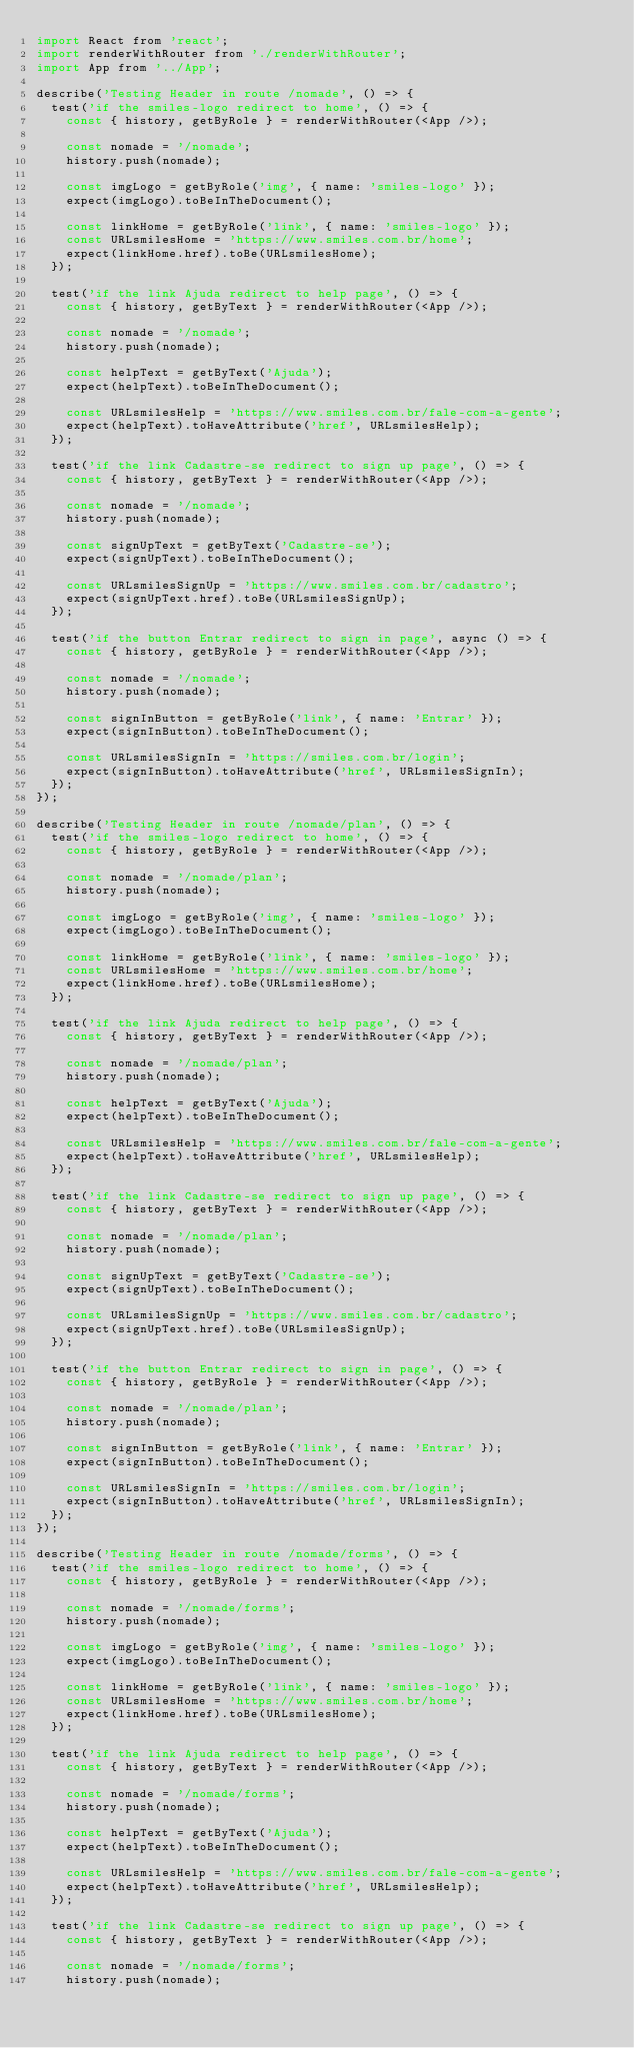Convert code to text. <code><loc_0><loc_0><loc_500><loc_500><_JavaScript_>import React from 'react';
import renderWithRouter from './renderWithRouter';
import App from '../App';

describe('Testing Header in route /nomade', () => {
	test('if the smiles-logo redirect to home', () => {
		const { history, getByRole } = renderWithRouter(<App />);

		const nomade = '/nomade';
		history.push(nomade);

		const imgLogo = getByRole('img', { name: 'smiles-logo' });
		expect(imgLogo).toBeInTheDocument();

		const linkHome = getByRole('link', { name: 'smiles-logo' });
		const URLsmilesHome = 'https://www.smiles.com.br/home';
		expect(linkHome.href).toBe(URLsmilesHome);
	});
	
	test('if the link Ajuda redirect to help page', () => {
		const { history, getByText } = renderWithRouter(<App />);
		
		const nomade = '/nomade';
		history.push(nomade);

		const helpText = getByText('Ajuda');
		expect(helpText).toBeInTheDocument();

		const URLsmilesHelp = 'https://www.smiles.com.br/fale-com-a-gente';
		expect(helpText).toHaveAttribute('href', URLsmilesHelp);
	});

	test('if the link Cadastre-se redirect to sign up page', () => {
		const { history, getByText } = renderWithRouter(<App />);
		
		const nomade = '/nomade';
		history.push(nomade);

		const signUpText = getByText('Cadastre-se');
		expect(signUpText).toBeInTheDocument();

		const URLsmilesSignUp = 'https://www.smiles.com.br/cadastro';
		expect(signUpText.href).toBe(URLsmilesSignUp);
	});

	test('if the button Entrar redirect to sign in page', async () => {
		const { history, getByRole } = renderWithRouter(<App />);
		
		const nomade = '/nomade';
		history.push(nomade);

		const signInButton = getByRole('link', { name: 'Entrar' });
		expect(signInButton).toBeInTheDocument();

		const URLsmilesSignIn = 'https://smiles.com.br/login';
		expect(signInButton).toHaveAttribute('href', URLsmilesSignIn);
	});
});

describe('Testing Header in route /nomade/plan', () => {
	test('if the smiles-logo redirect to home', () => {
		const { history, getByRole } = renderWithRouter(<App />);

		const nomade = '/nomade/plan';
		history.push(nomade);

		const imgLogo = getByRole('img', { name: 'smiles-logo' });
		expect(imgLogo).toBeInTheDocument();

		const linkHome = getByRole('link', { name: 'smiles-logo' });
		const URLsmilesHome = 'https://www.smiles.com.br/home';
		expect(linkHome.href).toBe(URLsmilesHome);
	});
	
	test('if the link Ajuda redirect to help page', () => {
		const { history, getByText } = renderWithRouter(<App />);
		
		const nomade = '/nomade/plan';
		history.push(nomade);

		const helpText = getByText('Ajuda');
		expect(helpText).toBeInTheDocument();

		const URLsmilesHelp = 'https://www.smiles.com.br/fale-com-a-gente';
		expect(helpText).toHaveAttribute('href', URLsmilesHelp);
	});

	test('if the link Cadastre-se redirect to sign up page', () => {
		const { history, getByText } = renderWithRouter(<App />);
		
		const nomade = '/nomade/plan';
		history.push(nomade);

		const signUpText = getByText('Cadastre-se');
		expect(signUpText).toBeInTheDocument();

		const URLsmilesSignUp = 'https://www.smiles.com.br/cadastro';
		expect(signUpText.href).toBe(URLsmilesSignUp);
	});

	test('if the button Entrar redirect to sign in page', () => {
		const { history, getByRole } = renderWithRouter(<App />);
		
		const nomade = '/nomade/plan';
		history.push(nomade);

		const signInButton = getByRole('link', { name: 'Entrar' });
		expect(signInButton).toBeInTheDocument();

		const URLsmilesSignIn = 'https://smiles.com.br/login';
		expect(signInButton).toHaveAttribute('href', URLsmilesSignIn);
	});
});

describe('Testing Header in route /nomade/forms', () => {
	test('if the smiles-logo redirect to home', () => {
		const { history, getByRole } = renderWithRouter(<App />);

		const nomade = '/nomade/forms';
		history.push(nomade);

		const imgLogo = getByRole('img', { name: 'smiles-logo' });
		expect(imgLogo).toBeInTheDocument();

		const linkHome = getByRole('link', { name: 'smiles-logo' });
		const URLsmilesHome = 'https://www.smiles.com.br/home';
		expect(linkHome.href).toBe(URLsmilesHome);
	});
	
	test('if the link Ajuda redirect to help page', () => {
		const { history, getByText } = renderWithRouter(<App />);
		
		const nomade = '/nomade/forms';
		history.push(nomade);

		const helpText = getByText('Ajuda');
		expect(helpText).toBeInTheDocument();

		const URLsmilesHelp = 'https://www.smiles.com.br/fale-com-a-gente';
		expect(helpText).toHaveAttribute('href', URLsmilesHelp);
	});

	test('if the link Cadastre-se redirect to sign up page', () => {
		const { history, getByText } = renderWithRouter(<App />);
		
		const nomade = '/nomade/forms';
		history.push(nomade);
</code> 